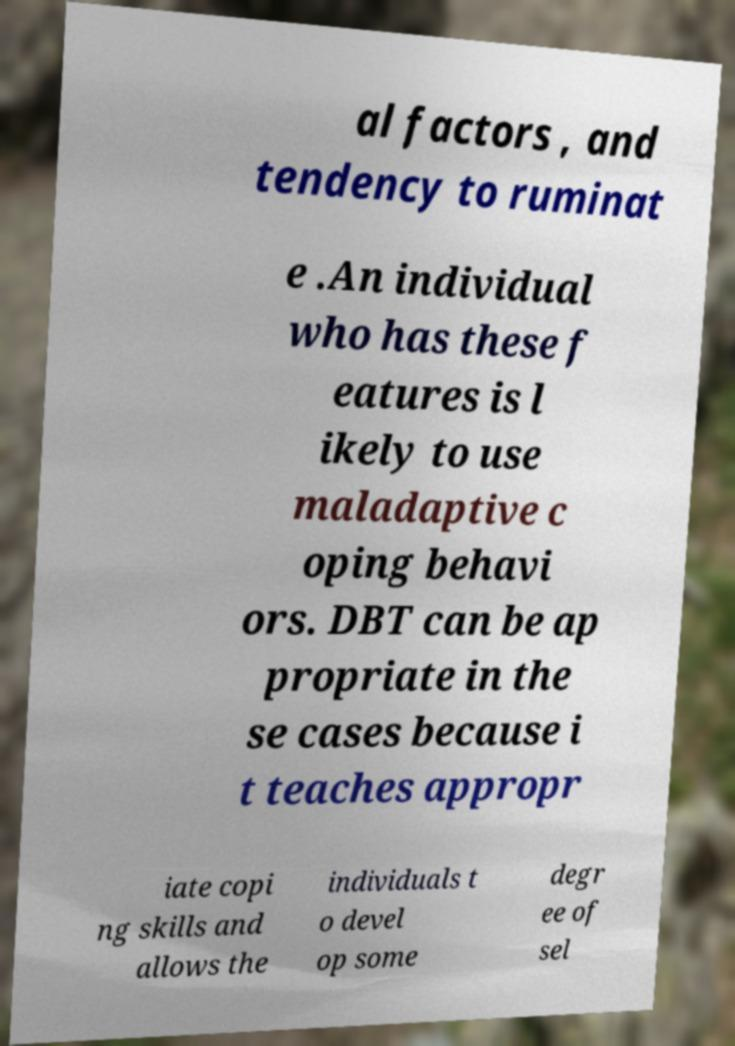Please read and relay the text visible in this image. What does it say? al factors , and tendency to ruminat e .An individual who has these f eatures is l ikely to use maladaptive c oping behavi ors. DBT can be ap propriate in the se cases because i t teaches appropr iate copi ng skills and allows the individuals t o devel op some degr ee of sel 